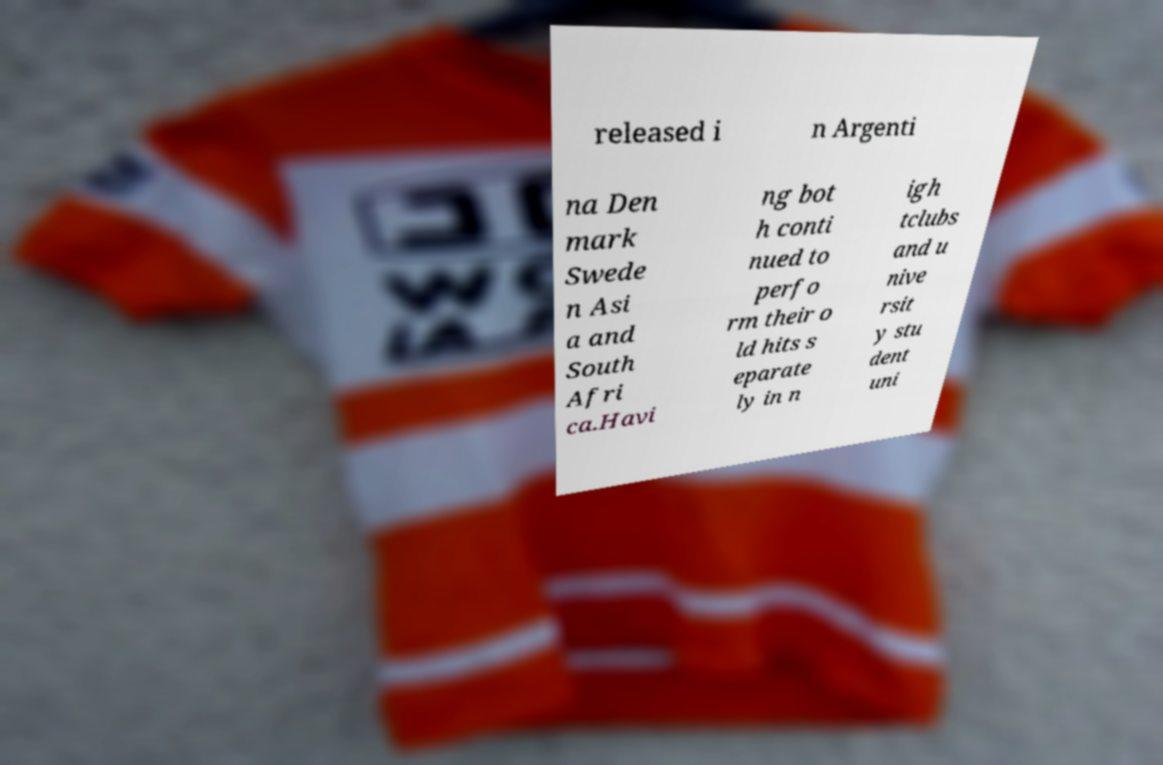There's text embedded in this image that I need extracted. Can you transcribe it verbatim? released i n Argenti na Den mark Swede n Asi a and South Afri ca.Havi ng bot h conti nued to perfo rm their o ld hits s eparate ly in n igh tclubs and u nive rsit y stu dent uni 